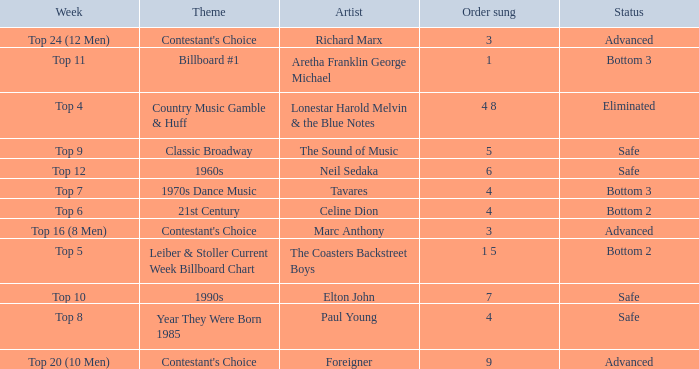What order was the performance of a Richard Marx song? 3.0. 